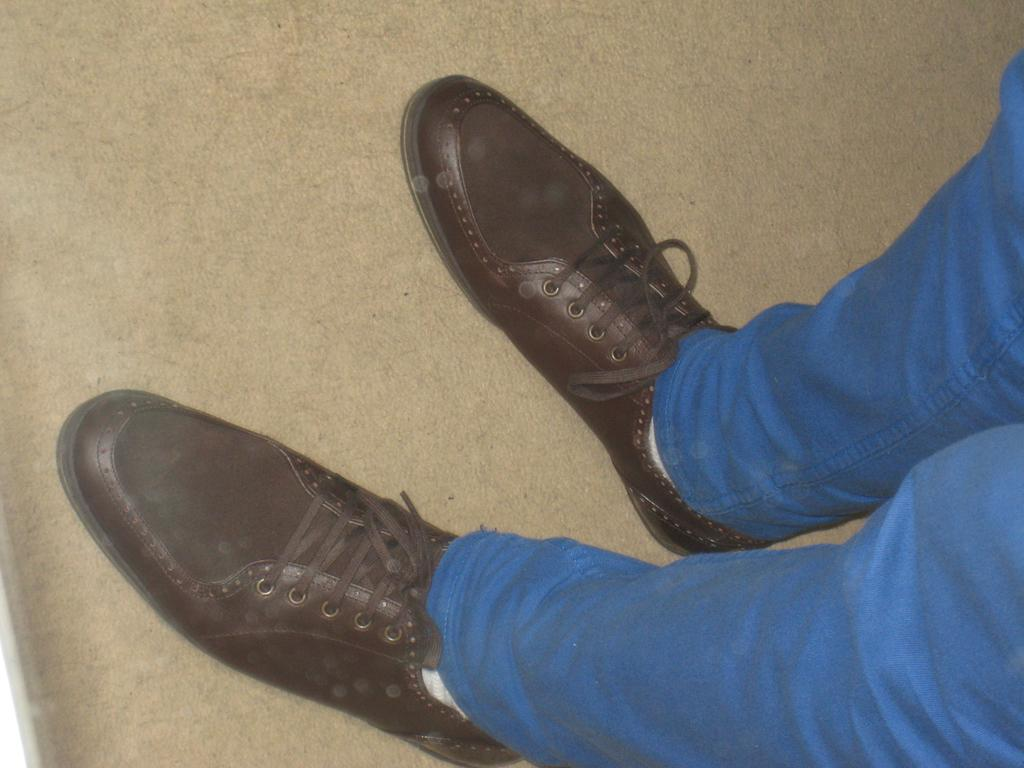What body part of a person can be seen in the image? There are legs of a person visible in the image. What type of footwear is the person wearing? The person is wearing shoes. Where are the legs located in the image? The legs are on the floor. What type of tent can be seen in the image? There is no tent present in the image; it only shows the legs of a person wearing shoes and standing on the floor. 